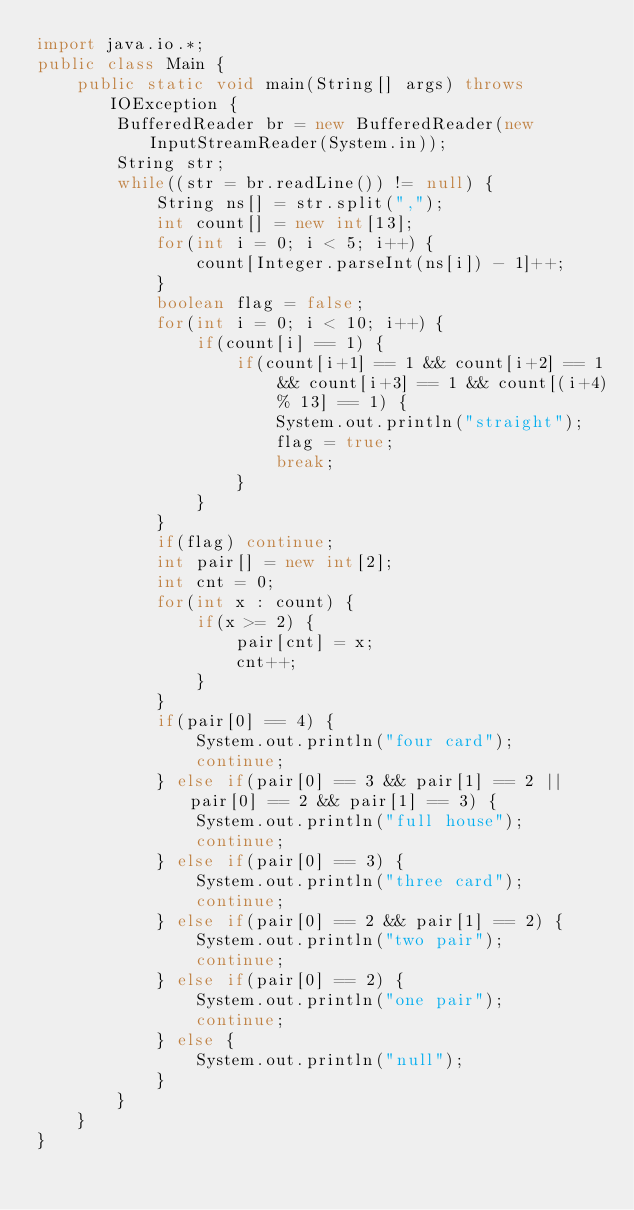<code> <loc_0><loc_0><loc_500><loc_500><_Java_>import java.io.*;
public class Main {
	public static void main(String[] args) throws IOException {
		BufferedReader br = new BufferedReader(new InputStreamReader(System.in));
		String str;
		while((str = br.readLine()) != null) {
			String ns[] = str.split(",");
			int count[] = new int[13];
			for(int i = 0; i < 5; i++) {
				count[Integer.parseInt(ns[i]) - 1]++;
			}
			boolean flag = false;
			for(int i = 0; i < 10; i++) {
				if(count[i] == 1) {
					if(count[i+1] == 1 && count[i+2] == 1 && count[i+3] == 1 && count[(i+4) % 13] == 1) {
						System.out.println("straight");
						flag = true;
						break;
					}
				}
			}
			if(flag) continue;
			int pair[] = new int[2];
			int cnt = 0;
			for(int x : count) {				
				if(x >= 2) {
					pair[cnt] = x;
					cnt++;
				}
			}
			if(pair[0] == 4) {
				System.out.println("four card");
				continue;
			} else if(pair[0] == 3 && pair[1] == 2 || pair[0] == 2 && pair[1] == 3) {
				System.out.println("full house");
				continue;
			} else if(pair[0] == 3) {
				System.out.println("three card");
				continue;
			} else if(pair[0] == 2 && pair[1] == 2) {
				System.out.println("two pair");
				continue;
			} else if(pair[0] == 2) {
				System.out.println("one pair");
				continue;
			} else {
				System.out.println("null");
			}
		}
	}
}</code> 